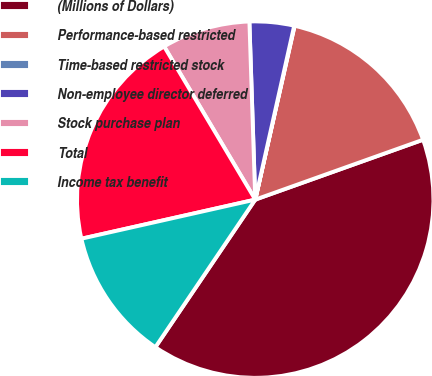<chart> <loc_0><loc_0><loc_500><loc_500><pie_chart><fcel>(Millions of Dollars)<fcel>Performance-based restricted<fcel>Time-based restricted stock<fcel>Non-employee director deferred<fcel>Stock purchase plan<fcel>Total<fcel>Income tax benefit<nl><fcel>39.93%<fcel>16.0%<fcel>0.04%<fcel>4.03%<fcel>8.02%<fcel>19.98%<fcel>12.01%<nl></chart> 